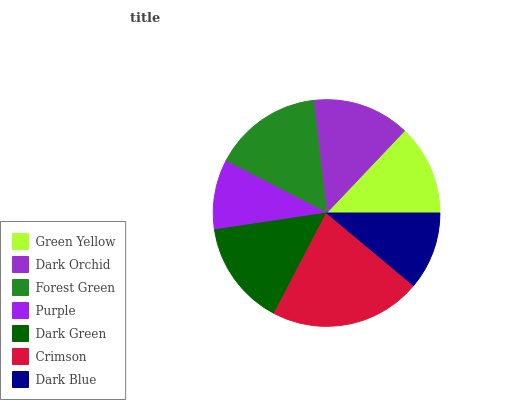Is Purple the minimum?
Answer yes or no. Yes. Is Crimson the maximum?
Answer yes or no. Yes. Is Dark Orchid the minimum?
Answer yes or no. No. Is Dark Orchid the maximum?
Answer yes or no. No. Is Dark Orchid greater than Green Yellow?
Answer yes or no. Yes. Is Green Yellow less than Dark Orchid?
Answer yes or no. Yes. Is Green Yellow greater than Dark Orchid?
Answer yes or no. No. Is Dark Orchid less than Green Yellow?
Answer yes or no. No. Is Dark Orchid the high median?
Answer yes or no. Yes. Is Dark Orchid the low median?
Answer yes or no. Yes. Is Purple the high median?
Answer yes or no. No. Is Dark Blue the low median?
Answer yes or no. No. 